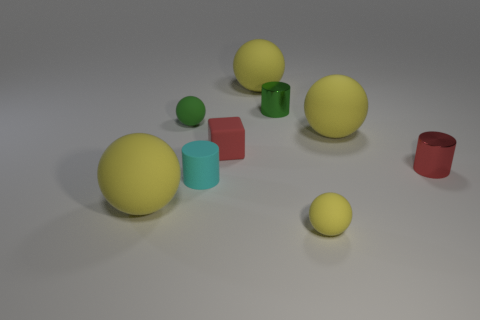What is the shape of the tiny red thing that is on the left side of the tiny rubber object in front of the large matte sphere on the left side of the red matte object? The tiny red object to the left of the rubber item, which is positioned in front of the large matte sphere on the left side of the more prominent red matte object, is a cube. This small geometric figure features distinct edges and flat faces characteristic of a cube's shape. 